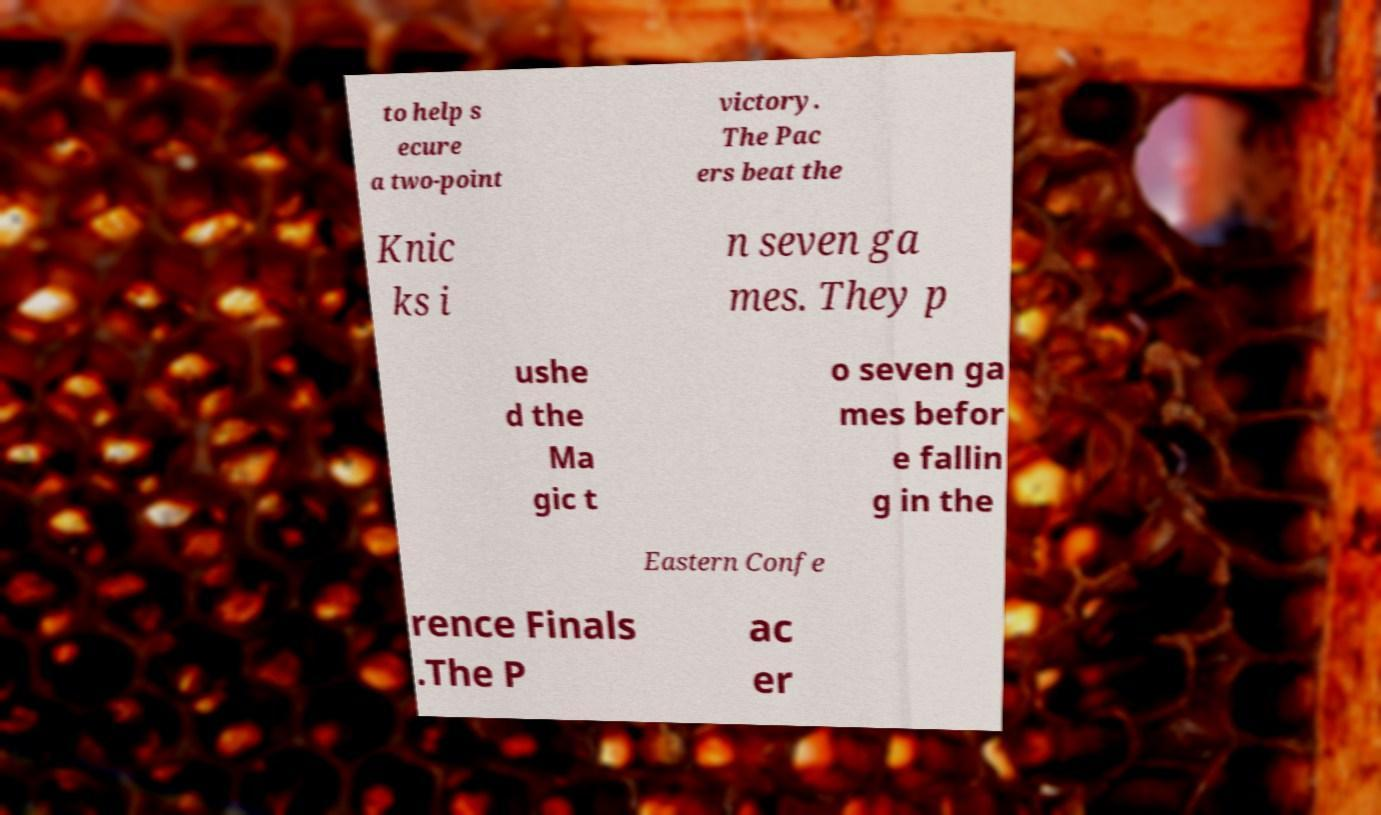Please identify and transcribe the text found in this image. to help s ecure a two-point victory. The Pac ers beat the Knic ks i n seven ga mes. They p ushe d the Ma gic t o seven ga mes befor e fallin g in the Eastern Confe rence Finals .The P ac er 